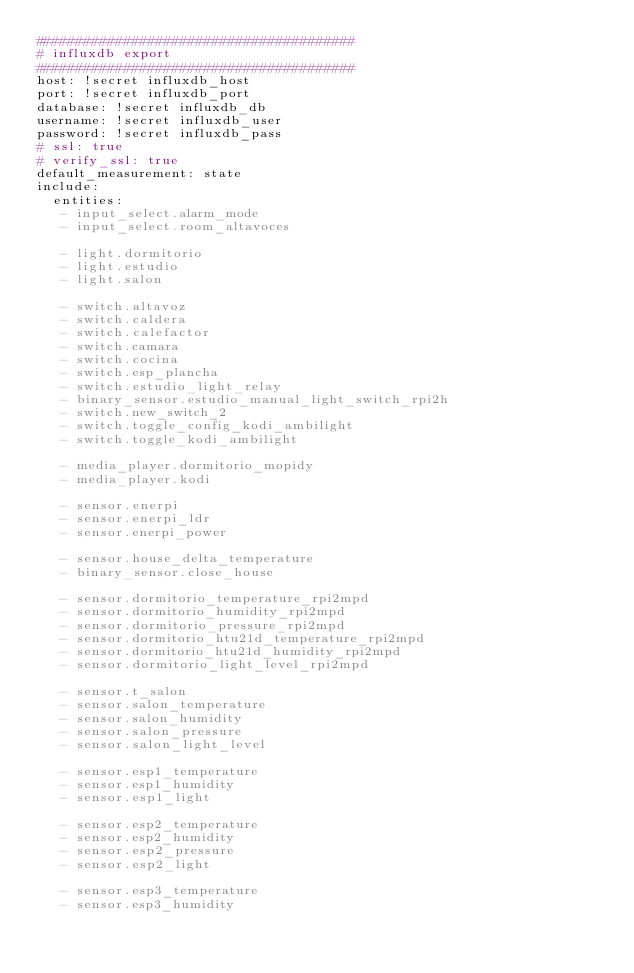<code> <loc_0><loc_0><loc_500><loc_500><_YAML_>########################################
# influxdb export
########################################
host: !secret influxdb_host
port: !secret influxdb_port
database: !secret influxdb_db
username: !secret influxdb_user
password: !secret influxdb_pass
# ssl: true
# verify_ssl: true
default_measurement: state
include:
  entities:
   - input_select.alarm_mode
   - input_select.room_altavoces

   - light.dormitorio
   - light.estudio
   - light.salon

   - switch.altavoz
   - switch.caldera
   - switch.calefactor
   - switch.camara
   - switch.cocina
   - switch.esp_plancha
   - switch.estudio_light_relay
   - binary_sensor.estudio_manual_light_switch_rpi2h
   - switch.new_switch_2
   - switch.toggle_config_kodi_ambilight
   - switch.toggle_kodi_ambilight

   - media_player.dormitorio_mopidy
   - media_player.kodi

   - sensor.enerpi
   - sensor.enerpi_ldr
   - sensor.enerpi_power

   - sensor.house_delta_temperature
   - binary_sensor.close_house

   - sensor.dormitorio_temperature_rpi2mpd
   - sensor.dormitorio_humidity_rpi2mpd
   - sensor.dormitorio_pressure_rpi2mpd
   - sensor.dormitorio_htu21d_temperature_rpi2mpd
   - sensor.dormitorio_htu21d_humidity_rpi2mpd
   - sensor.dormitorio_light_level_rpi2mpd

   - sensor.t_salon
   - sensor.salon_temperature
   - sensor.salon_humidity
   - sensor.salon_pressure
   - sensor.salon_light_level

   - sensor.esp1_temperature
   - sensor.esp1_humidity
   - sensor.esp1_light

   - sensor.esp2_temperature
   - sensor.esp2_humidity
   - sensor.esp2_pressure
   - sensor.esp2_light

   - sensor.esp3_temperature
   - sensor.esp3_humidity</code> 